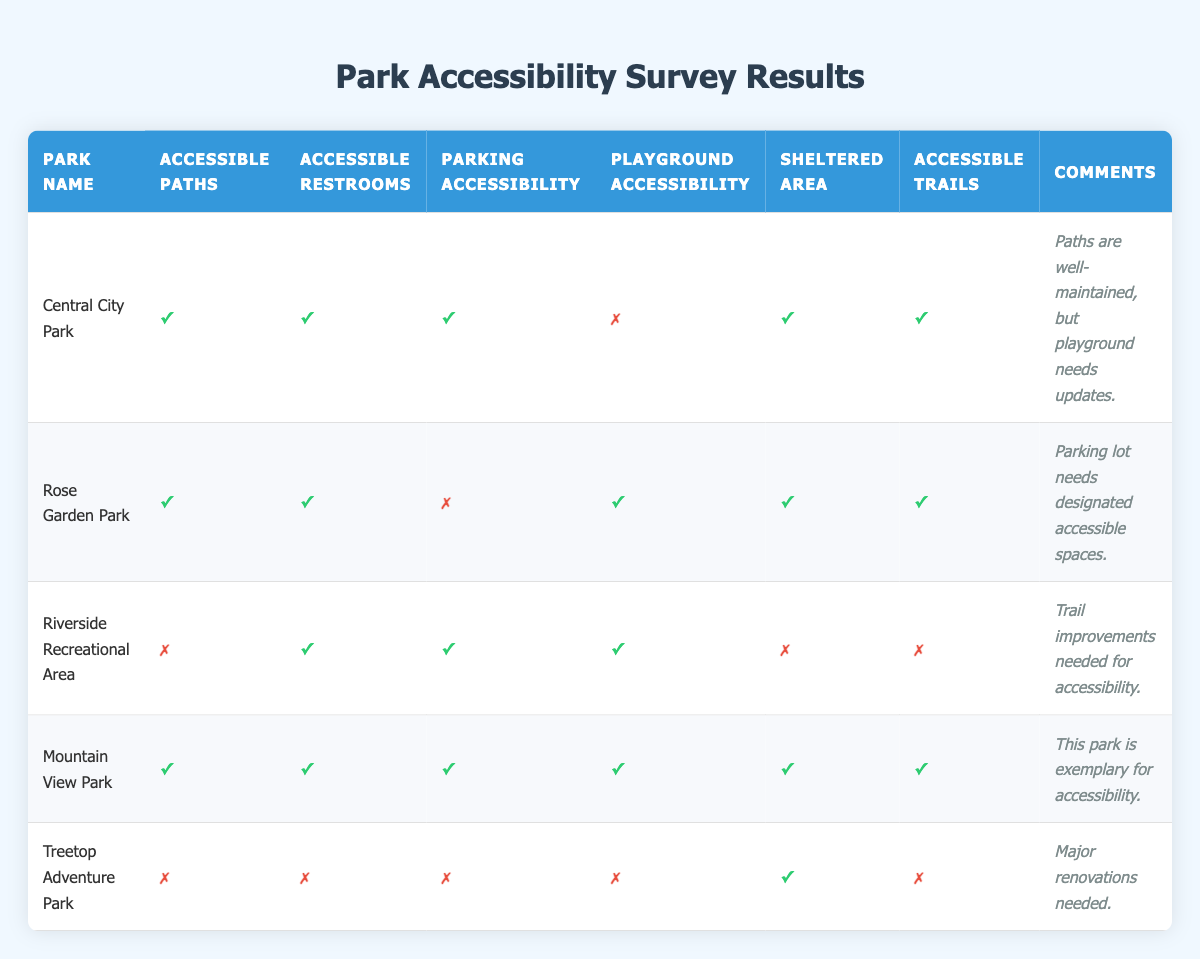What parks have accessible paths? By reviewing the table, I see that "Central City Park," "Rose Garden Park," "Mountain View Park" all have accessible paths marked as true. "Riverside Recreational Area" and "Treetop Adventure Park" do not have accessible paths.
Answer: Central City Park, Rose Garden Park, Mountain View Park Which park lacks all accessible features listed? Looking at the table, "Treetop Adventure Park" is the only park that has all features (accessible paths, restrooms, parking, playground, trails) marked as false.
Answer: Treetop Adventure Park How many parks have accessible restrooms? By counting the rows in the table, I find that "Central City Park," "Rose Garden Park," "Riverside Recreational Area," and "Mountain View Park" all have accessible restrooms marked as true. This gives a total of 4 parks.
Answer: 4 Which park has the most accessible features overall? I compare the Boolean values of all features for each park. "Mountain View Park" has all categories marked as true, indicating the most accessibility features.
Answer: Mountain View Park Is there a park that has both accessible restrooms and parking accessibility but lacks accessible paths? I review the table and identify "Riverside Recreational Area," which has accessible restrooms and parking but does not have accessible paths marked as true.
Answer: Yes, Riverside Recreational Area What percentage of parks have playground accessibility? There are 5 parks listed. "Central City Park," "Rose Garden Park," "Riverside Recreational Area," and "Mountain View Park" have playground accessibility marked as true. This is 4 out of 5 parks, resulting in 80 percent.
Answer: 80 percent Which parks provide sheltered areas but lack accessible trails? From the table, "Riverside Recreational Area" does not have accessible trails while "Treetop Adventure Park," also provides a sheltered area but lacks accessible trails. Thus, both parks fulfill this criterion.
Answer: Riverside Recreational Area, Treetop Adventure Park How many parks need updates based on the comments? Analyzing the comments, "Central City Park" mentions needing updates for the playground, "Rose Garden Park" states parking lot needs accessible spaces, and "Treetop Adventure Park" specifies major renovations are needed. Thus, 3 parks need updates mentioned.
Answer: 3 